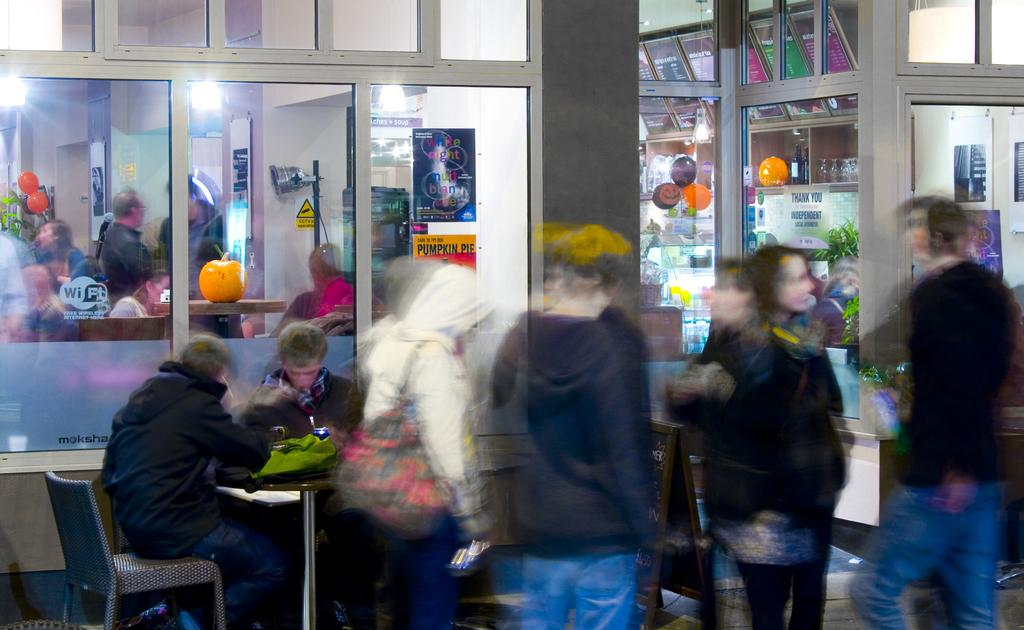How many people are sitting on chairs in the image? There are two persons sitting on chairs on the left side of the image. What are the people on the right side of the image doing? The people on the right side of the image are standing and talking to each other. What type of clouds can be seen in the image? There are no clouds visible in the image, as it is focused on the people sitting and standing. How does the coil affect the control of the image? There is no coil or control mentioned in the image, as it is a static photograph. 